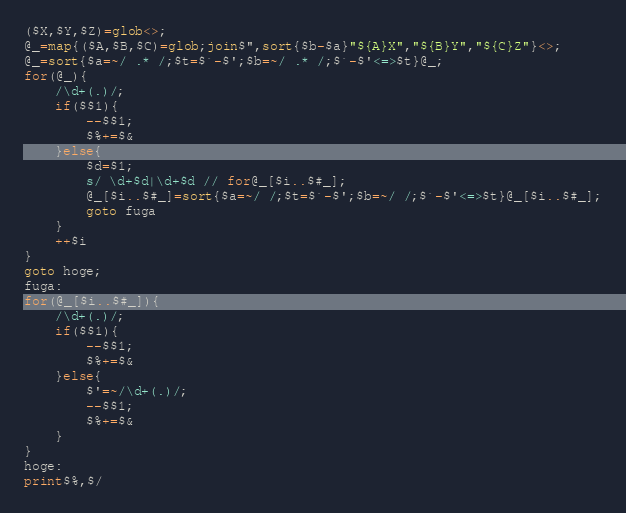Convert code to text. <code><loc_0><loc_0><loc_500><loc_500><_Perl_>($X,$Y,$Z)=glob<>;
@_=map{($A,$B,$C)=glob;join$",sort{$b-$a}"${A}X","${B}Y","${C}Z"}<>;
@_=sort{$a=~/ .* /;$t=$`-$';$b=~/ .* /;$`-$'<=>$t}@_;
for(@_){
	/\d+(.)/;
	if($$1){
		--$$1;
		$%+=$&
	}else{
		$d=$1;
		s/ \d+$d|\d+$d // for@_[$i..$#_];
		@_[$i..$#_]=sort{$a=~/ /;$t=$`-$';$b=~/ /;$`-$'<=>$t}@_[$i..$#_];
		goto fuga
	}
	++$i
}
goto hoge;
fuga:
for(@_[$i..$#_]){
	/\d+(.)/;
	if($$1){
		--$$1;
		$%+=$&
	}else{
		$'=~/\d+(.)/;
		--$$1;
		$%+=$&
	}
}
hoge:
print$%,$/
</code> 